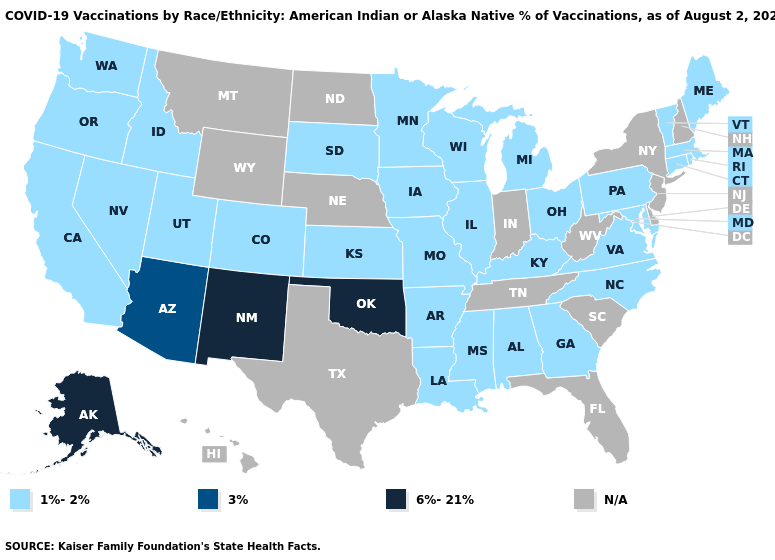What is the highest value in states that border Rhode Island?
Keep it brief. 1%-2%. What is the lowest value in the MidWest?
Short answer required. 1%-2%. Is the legend a continuous bar?
Concise answer only. No. Name the states that have a value in the range N/A?
Concise answer only. Delaware, Florida, Hawaii, Indiana, Montana, Nebraska, New Hampshire, New Jersey, New York, North Dakota, South Carolina, Tennessee, Texas, West Virginia, Wyoming. What is the value of Massachusetts?
Give a very brief answer. 1%-2%. Is the legend a continuous bar?
Write a very short answer. No. Among the states that border California , which have the lowest value?
Be succinct. Nevada, Oregon. Name the states that have a value in the range 3%?
Quick response, please. Arizona. What is the lowest value in the USA?
Quick response, please. 1%-2%. What is the value of Texas?
Give a very brief answer. N/A. What is the value of Indiana?
Give a very brief answer. N/A. How many symbols are there in the legend?
Quick response, please. 4. Among the states that border Colorado , does New Mexico have the lowest value?
Write a very short answer. No. Name the states that have a value in the range 3%?
Write a very short answer. Arizona. 